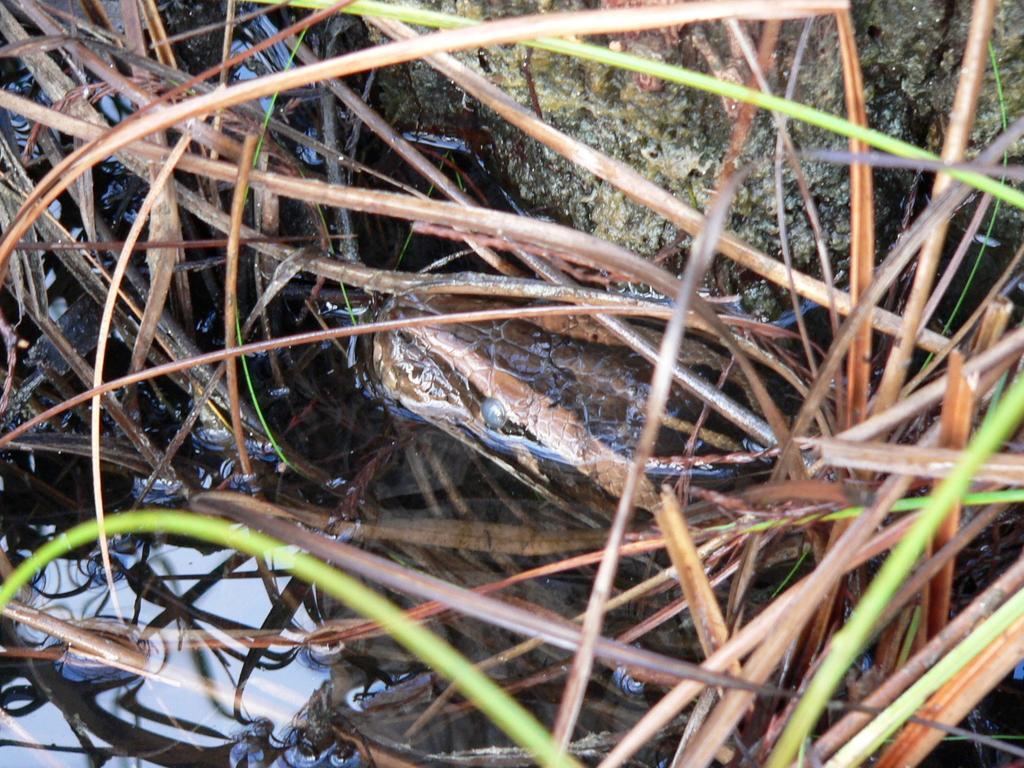Can you describe this image briefly? In this picture we can see snake, water, grass and rock. 